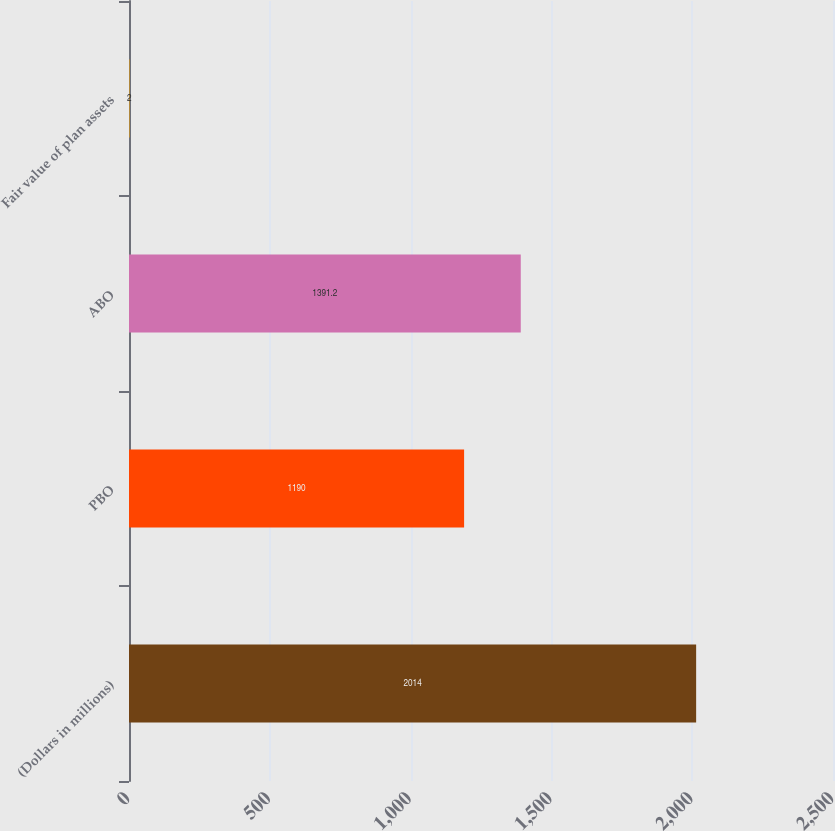<chart> <loc_0><loc_0><loc_500><loc_500><bar_chart><fcel>(Dollars in millions)<fcel>PBO<fcel>ABO<fcel>Fair value of plan assets<nl><fcel>2014<fcel>1190<fcel>1391.2<fcel>2<nl></chart> 